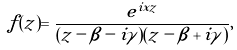<formula> <loc_0><loc_0><loc_500><loc_500>f ( z ) = \frac { e ^ { i x z } } { ( z - \beta - i \gamma ) ( z - \beta + i \gamma ) } ,</formula> 